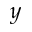<formula> <loc_0><loc_0><loc_500><loc_500>_ { y }</formula> 